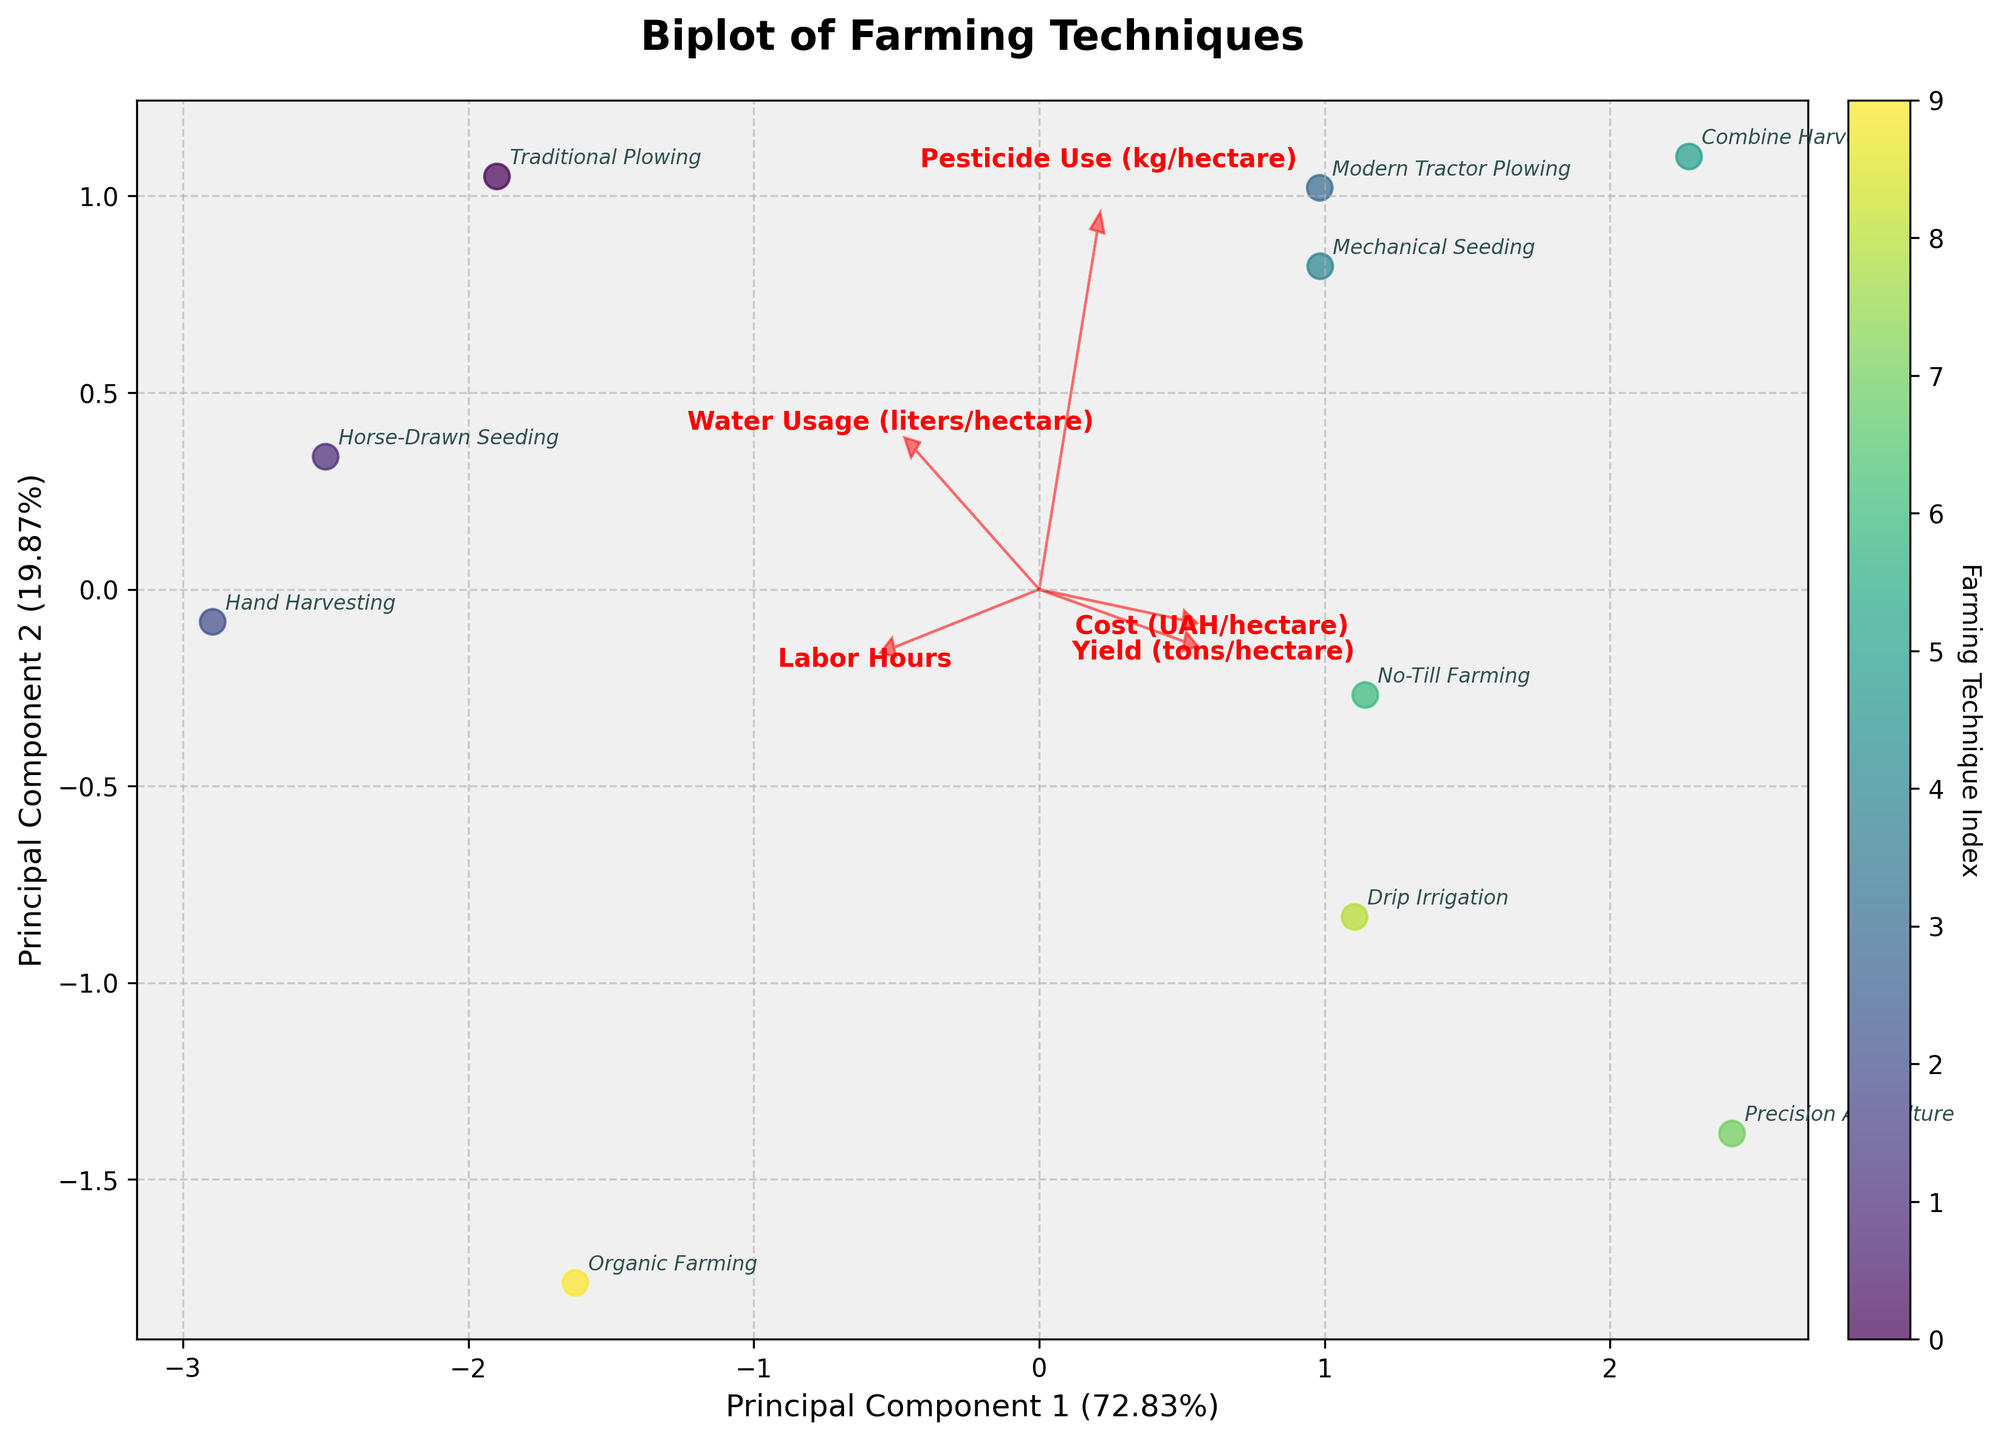What's the title of the plot? The title of the plot is typically positioned at the top center. By reading this, you can identify the overall focus of the figure.
Answer: Biplot of Farming Techniques How many farming techniques are represented in the figure? Each unique data point in the scatter plot represents a farming technique. By counting these points, you can determine the number of techniques compared.
Answer: 10 Which farming technique is closest to the origin (0,0) in the plot? The origin represents the average of all standardized features. By observing the distance of each data point from the origin, you can identify the closest technique.
Answer: Organic Farming What feature vector is most aligned with Principal Component 1? Feature vectors are represented as red arrows. The alignment with the Principal Component 1 is indicated by how horizontal the arrow is.
Answer: Yield (tons/hectare) Which technique uses the least labor hours? The direction of the "Labor Hours" feature vector (red arrow) will point toward techniques with lower labor hours. By observing the positioning of techniques along this arrow, you can identify the one with the least labor hours.
Answer: Combine Harvesting Which technique exhibits the highest yield value? The "Yield (tons/hectare)" vector points toward higher yield values. By observing the points near the end of this vector, you can determine which technique has the highest yield.
Answer: Precision Agriculture Compare the cost efficiency between Modern Tractor Plowing and Drip Irrigation? The "Cost (UAH/hectare)" vector direction helps compare these techniques. Observe their positions relative to this vector to understand cost differences.
Answer: Drip Irrigation is more cost-efficient Which technique appears to be the most water-efficient? The "Water Usage (liters/hectare)" vector indicates water efficiency. Techniques positioned opposite to the arrow use less water.
Answer: Precision Agriculture How does No-Till Farming compare to Traditional Plowing in terms of yield and labor hours? Compare both techniques' positions relative to "Yield (tons/hectare)" and "Labor Hours" vectors. Observe if one has higher yield or lower labor hours compared to the other.
Answer: No-Till Farming has higher yield and fewer labor hours Identify the cluster of modern farming techniques on the plot. Modern techniques tend to cluster, showing similarities. By observing where these techniques (such as Modern Tractor Plowing, Mechanical Seeding, Combine Harvesting) group together, you can identify the cluster.
Answer: Upper left quadrant 